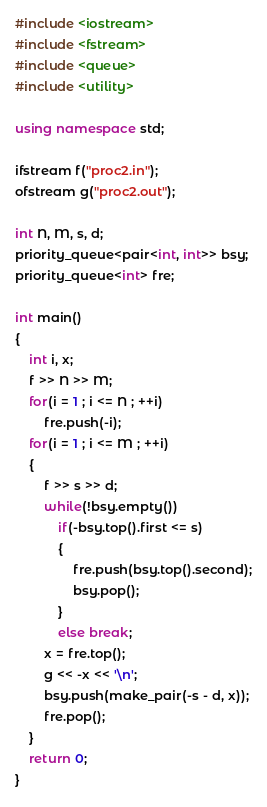<code> <loc_0><loc_0><loc_500><loc_500><_C++_>#include <iostream>
#include <fstream>
#include <queue>
#include <utility>

using namespace std;

ifstream f("proc2.in");
ofstream g("proc2.out");

int N, M, s, d;
priority_queue<pair<int, int>> bsy;
priority_queue<int> fre;

int main()
{
    int i, x;
    f >> N >> M;
    for(i = 1 ; i <= N ; ++i)
        fre.push(-i);
    for(i = 1 ; i <= M ; ++i)
    {
        f >> s >> d;
        while(!bsy.empty())
            if(-bsy.top().first <= s)
            {
                fre.push(bsy.top().second);
                bsy.pop();
            }
            else break;
        x = fre.top();
        g << -x << '\n';
        bsy.push(make_pair(-s - d, x));
        fre.pop();
    }
    return 0;
}
</code> 